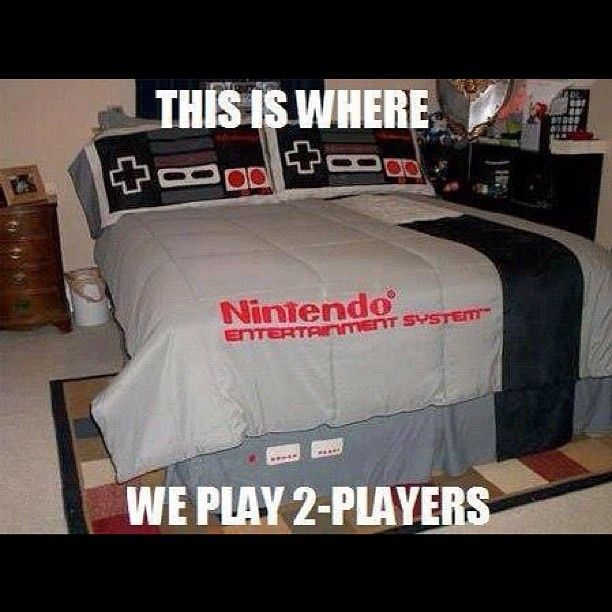Describe the objects in this image and their specific colors. I can see a bed in black, darkgray, and gray tones in this image. 